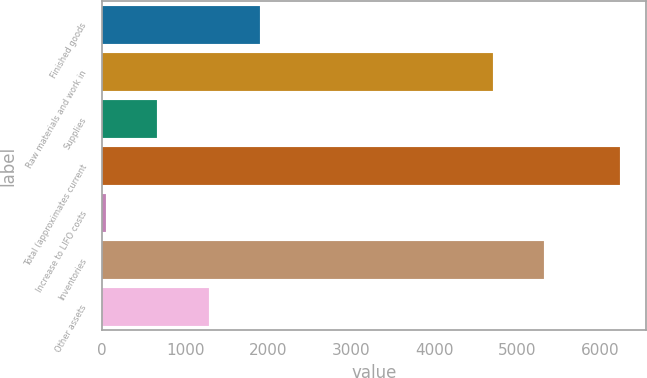<chart> <loc_0><loc_0><loc_500><loc_500><bar_chart><fcel>Finished goods<fcel>Raw materials and work in<fcel>Supplies<fcel>Total (approximates current<fcel>Increase to LIFO costs<fcel>Inventories<fcel>Other assets<nl><fcel>1902.9<fcel>4703<fcel>664.3<fcel>6238<fcel>45<fcel>5322.3<fcel>1283.6<nl></chart> 